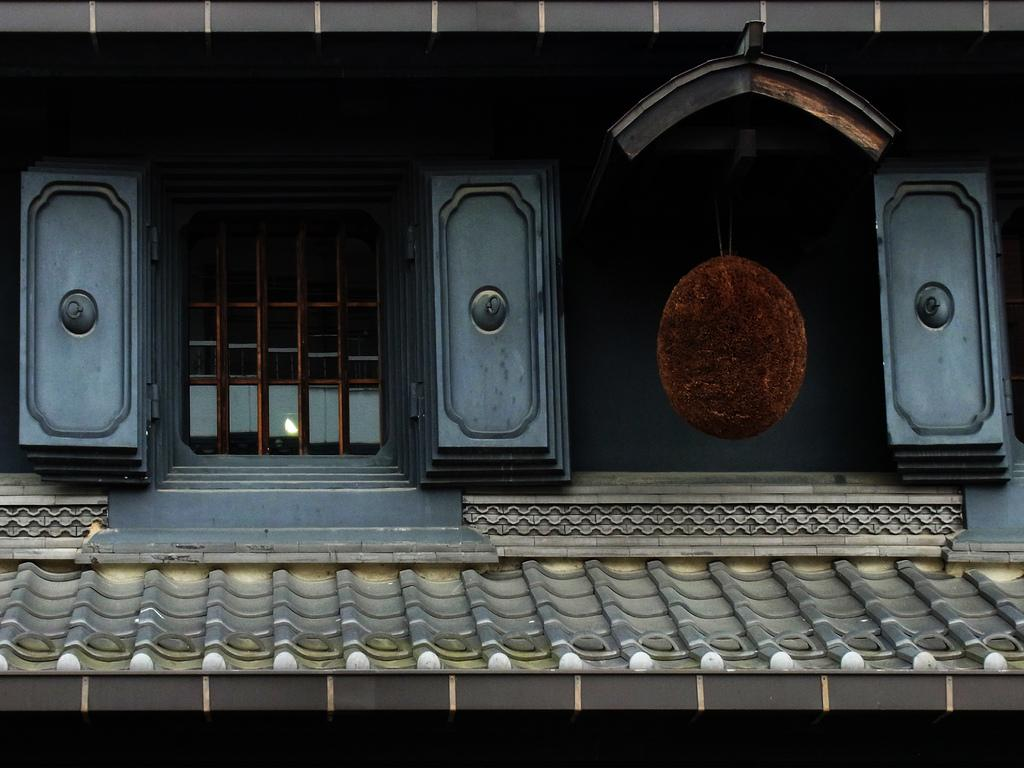What is located at the bottom of the image? There is a roof at the bottom of the image. What can be seen in the center of the image? There is a window in the center of the image. What type of window covering is present in the image? There are blinds on the window. What type of structure is depicted in the image? The image appears to depict a building. How much wood is present in the image? There is no wood explicitly mentioned or visible in the image. How many drops of water can be seen falling from the window? There are no drops of water visible in the image. 